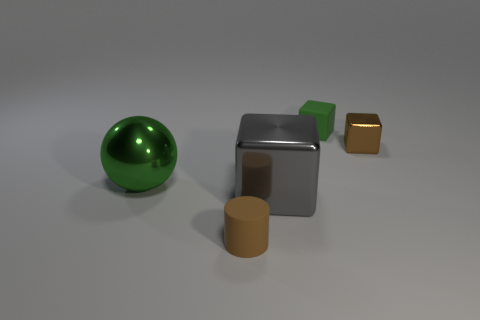Is there anything else that is the same shape as the tiny brown matte object?
Your response must be concise. No. There is a cylinder; what number of large green shiny balls are right of it?
Give a very brief answer. 0. What is the size of the matte object that is the same shape as the small brown metallic thing?
Give a very brief answer. Small. What number of gray things are spheres or big metal things?
Provide a short and direct response. 1. How many tiny brown objects are left of the big metal object that is on the right side of the ball?
Give a very brief answer. 1. How many other objects are the same shape as the large gray shiny thing?
Make the answer very short. 2. What is the material of the large sphere that is the same color as the small matte block?
Ensure brevity in your answer.  Metal. How many tiny matte cubes are the same color as the large ball?
Your answer should be very brief. 1. The big block that is the same material as the big green ball is what color?
Your response must be concise. Gray. Are there any other blocks that have the same size as the green rubber block?
Your answer should be very brief. Yes. 